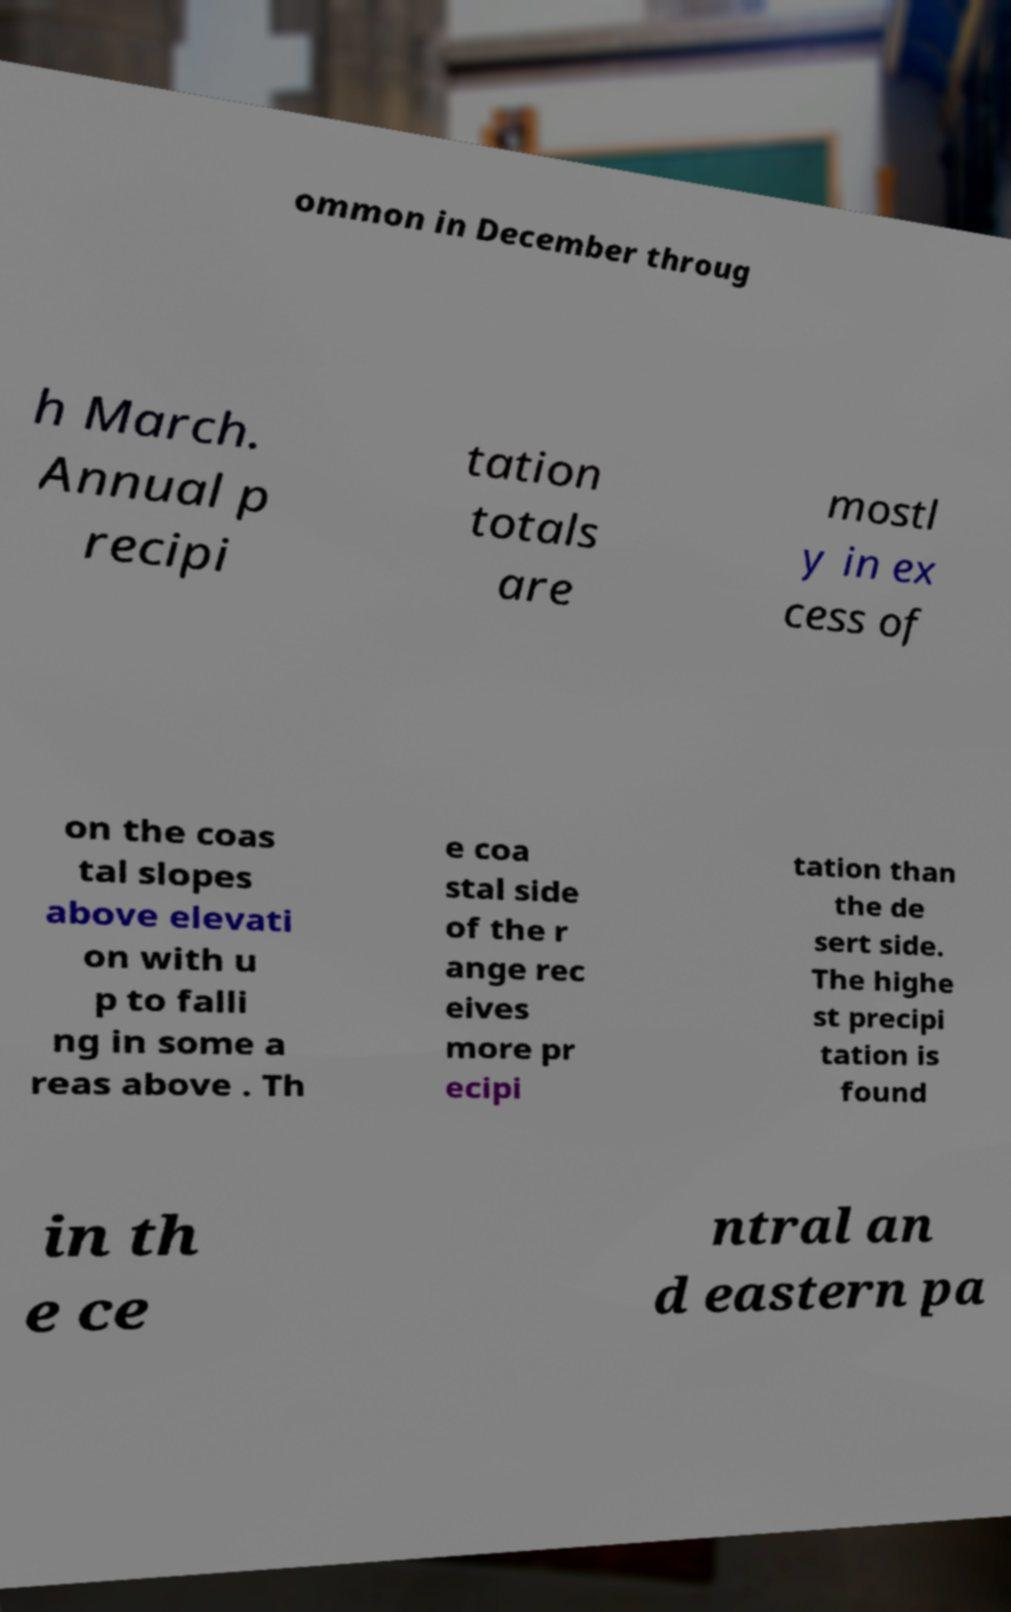Could you assist in decoding the text presented in this image and type it out clearly? ommon in December throug h March. Annual p recipi tation totals are mostl y in ex cess of on the coas tal slopes above elevati on with u p to falli ng in some a reas above . Th e coa stal side of the r ange rec eives more pr ecipi tation than the de sert side. The highe st precipi tation is found in th e ce ntral an d eastern pa 